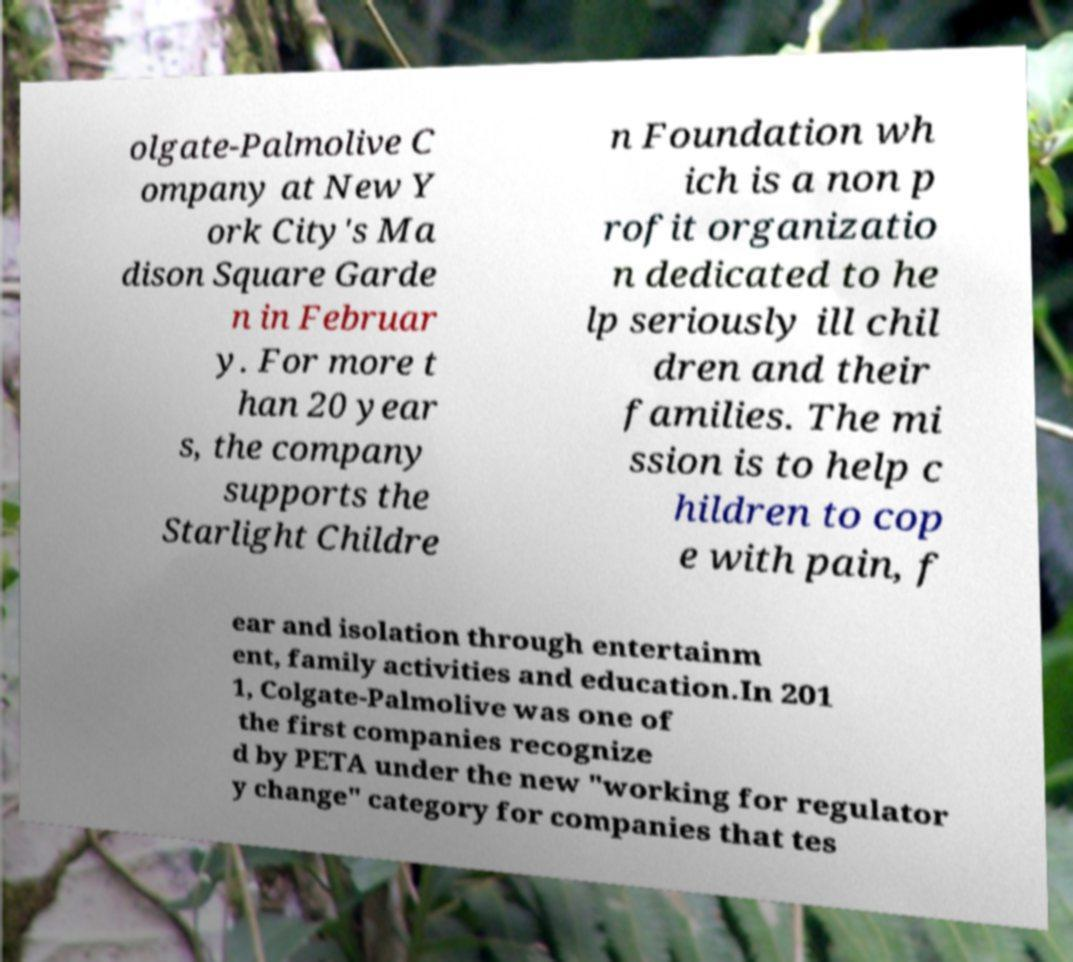Could you assist in decoding the text presented in this image and type it out clearly? olgate-Palmolive C ompany at New Y ork City's Ma dison Square Garde n in Februar y. For more t han 20 year s, the company supports the Starlight Childre n Foundation wh ich is a non p rofit organizatio n dedicated to he lp seriously ill chil dren and their families. The mi ssion is to help c hildren to cop e with pain, f ear and isolation through entertainm ent, family activities and education.In 201 1, Colgate-Palmolive was one of the first companies recognize d by PETA under the new "working for regulator y change" category for companies that tes 